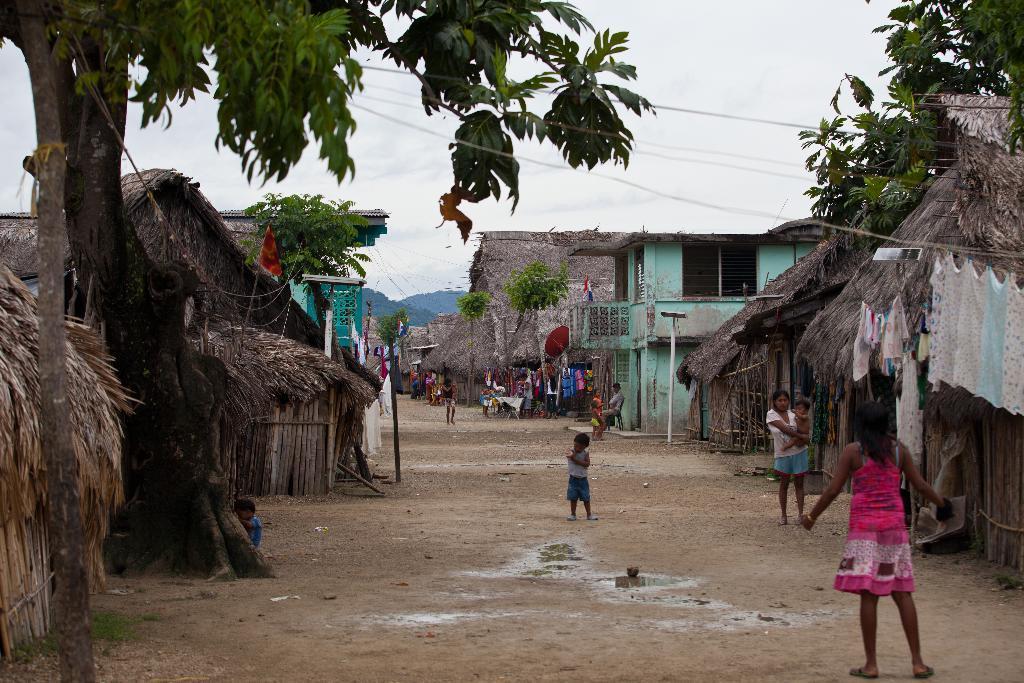Could you give a brief overview of what you see in this image? In this image there are houses and huts. In the center there is a path. There are people walking on the path. There are trees in the image. At the top there is the sky. In the background there are mountains. 